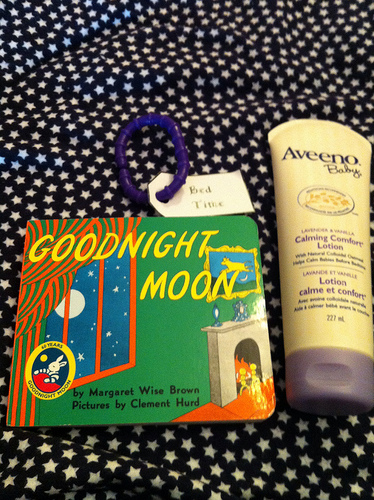<image>
Is the lotion in the book? No. The lotion is not contained within the book. These objects have a different spatial relationship. Where is the moon in relation to the blanket? Is it above the blanket? No. The moon is not positioned above the blanket. The vertical arrangement shows a different relationship. 